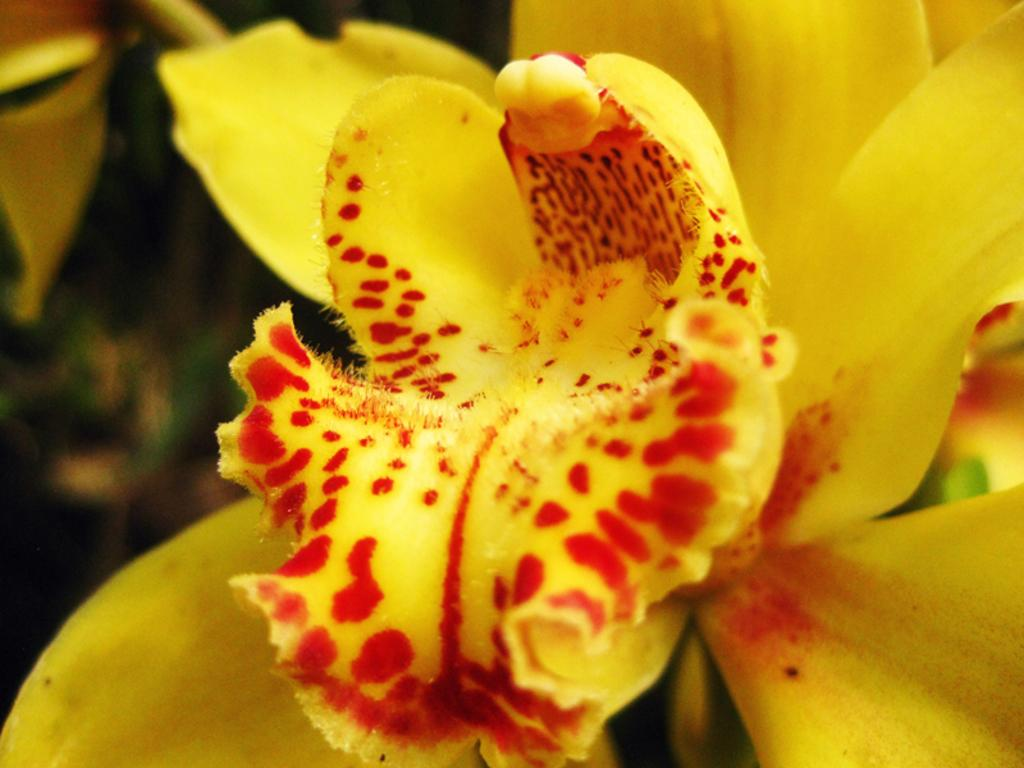What is the main subject of the image? There is a flower in the image. Can you describe the background of the image? The background of the image is blurred. How many goldfish can be seen swimming in the image? There are no goldfish present in the image; it features a flower with a blurred background. 